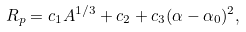<formula> <loc_0><loc_0><loc_500><loc_500>R _ { p } = c _ { 1 } A ^ { 1 / 3 } + c _ { 2 } + c _ { 3 } ( \alpha - \alpha _ { 0 } ) ^ { 2 } ,</formula> 